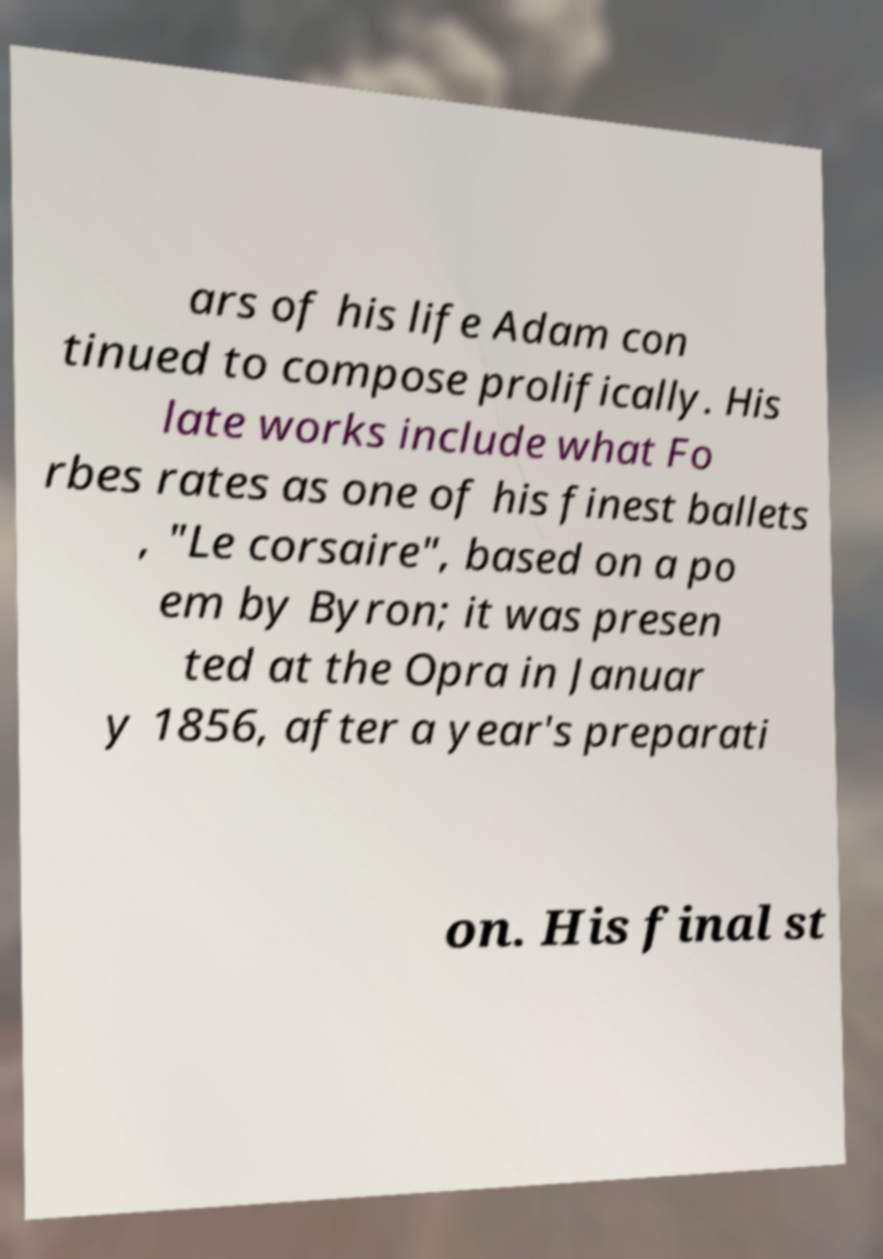Please read and relay the text visible in this image. What does it say? ars of his life Adam con tinued to compose prolifically. His late works include what Fo rbes rates as one of his finest ballets , "Le corsaire", based on a po em by Byron; it was presen ted at the Opra in Januar y 1856, after a year's preparati on. His final st 